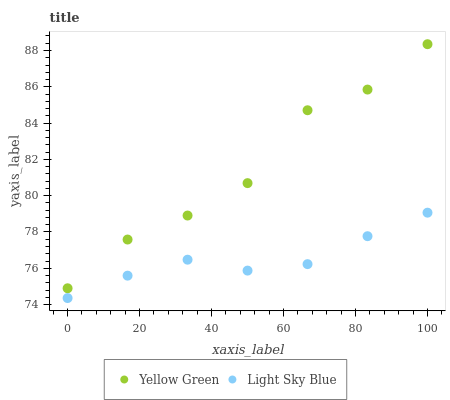Does Light Sky Blue have the minimum area under the curve?
Answer yes or no. Yes. Does Yellow Green have the maximum area under the curve?
Answer yes or no. Yes. Does Yellow Green have the minimum area under the curve?
Answer yes or no. No. Is Light Sky Blue the smoothest?
Answer yes or no. Yes. Is Yellow Green the roughest?
Answer yes or no. Yes. Is Yellow Green the smoothest?
Answer yes or no. No. Does Light Sky Blue have the lowest value?
Answer yes or no. Yes. Does Yellow Green have the lowest value?
Answer yes or no. No. Does Yellow Green have the highest value?
Answer yes or no. Yes. Is Light Sky Blue less than Yellow Green?
Answer yes or no. Yes. Is Yellow Green greater than Light Sky Blue?
Answer yes or no. Yes. Does Light Sky Blue intersect Yellow Green?
Answer yes or no. No. 